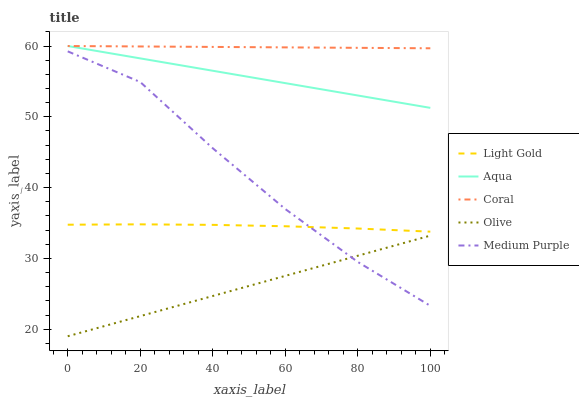Does Olive have the minimum area under the curve?
Answer yes or no. Yes. Does Coral have the maximum area under the curve?
Answer yes or no. Yes. Does Aqua have the minimum area under the curve?
Answer yes or no. No. Does Aqua have the maximum area under the curve?
Answer yes or no. No. Is Olive the smoothest?
Answer yes or no. Yes. Is Medium Purple the roughest?
Answer yes or no. Yes. Is Aqua the smoothest?
Answer yes or no. No. Is Aqua the roughest?
Answer yes or no. No. Does Aqua have the lowest value?
Answer yes or no. No. Does Light Gold have the highest value?
Answer yes or no. No. Is Medium Purple less than Coral?
Answer yes or no. Yes. Is Light Gold greater than Olive?
Answer yes or no. Yes. Does Medium Purple intersect Coral?
Answer yes or no. No. 